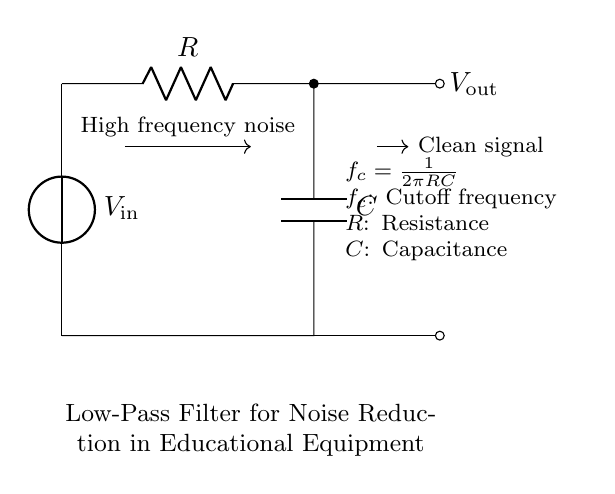What is the input voltage of the circuit? The input voltage is labeled as V_in at the top of the circuit diagram. It represents the voltage source supplying the filter.
Answer: V_in What components are in this low-pass filter? The circuit consists of a resistor and a capacitor, both indicated in the diagram as R and C respectively.
Answer: Resistor and Capacitor What is the purpose of this circuit? The purpose of the low-pass filter is to allow low-frequency signals to pass while attenuating high-frequency noise, as indicated in the description at the bottom of the diagram.
Answer: Noise reduction How is the output voltage generated in this circuit? The output voltage, labeled as V_out, is taken across the capacitor, from which the filtered (clean) signal is taken after noise reduction.
Answer: Across the capacitor What formula relates the cutoff frequency to the resistor and capacitor values? The cutoff frequency is given by the formula f_c equals one over two pi times R times C, which determines the frequency at which the output begins to drop off.
Answer: f_c = 1/2πRC What does the arrow pointing towards the output voltage represent? The arrow indicates the direction of the filtered signal output from the circuit, showing that this is where the clean signal can be accessed for further use.
Answer: Clean signal At what point does the high-frequency noise get attenuated? The high-frequency noise is attenuated primarily at the output, as the circuit is designed to decrease the amplitude of signals above the cutoff frequency.
Answer: At the output 